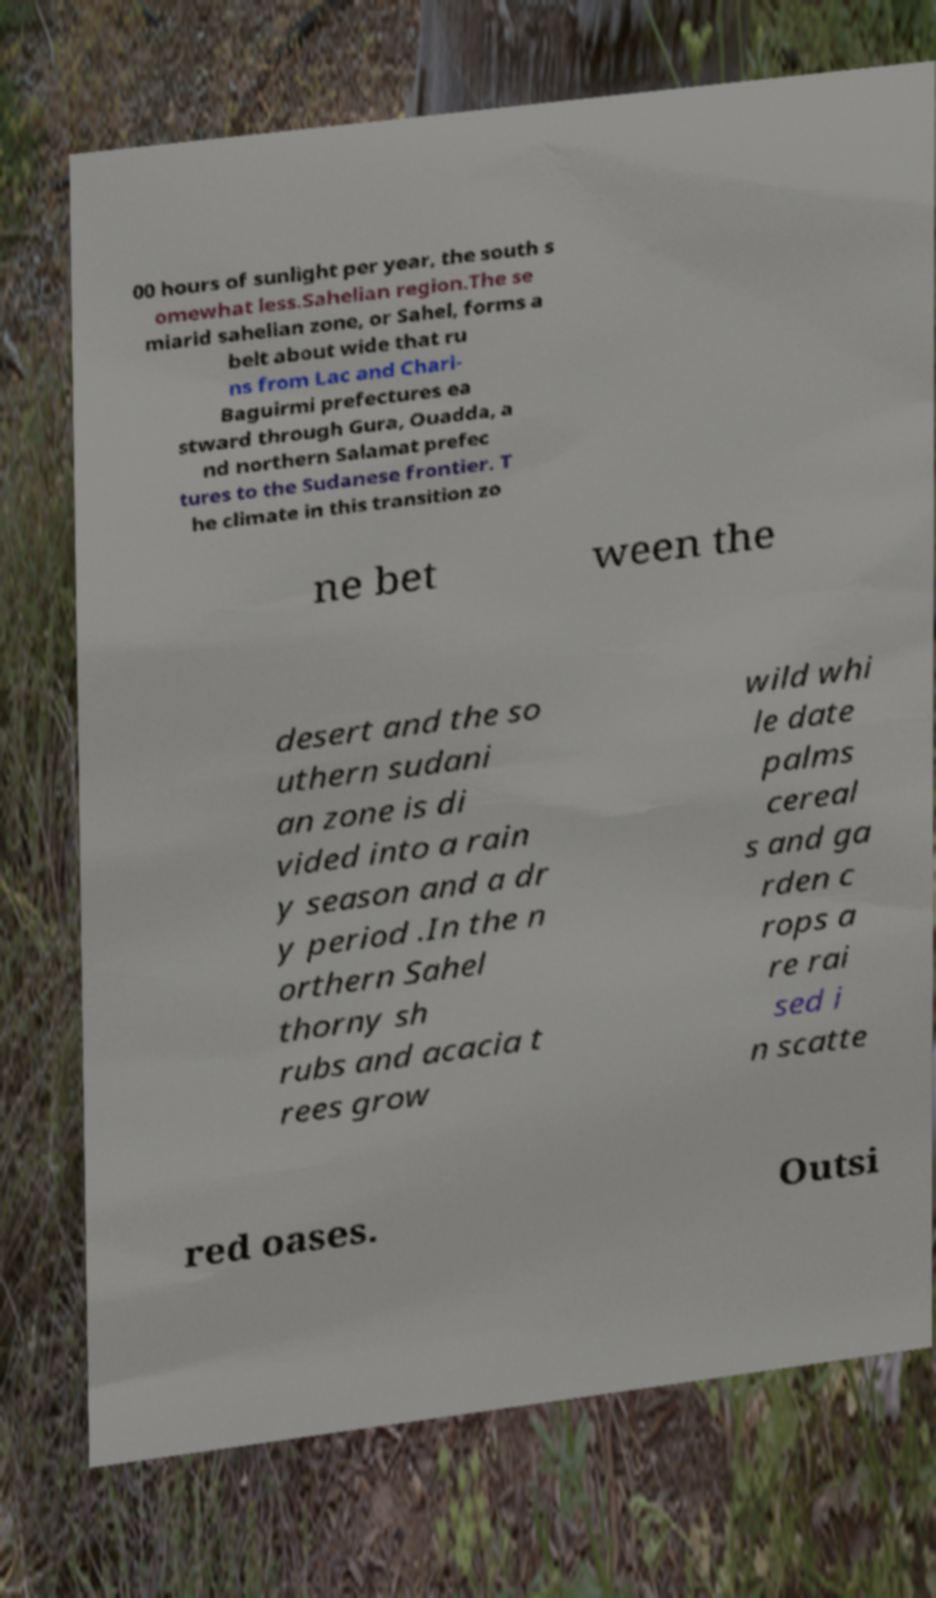Could you extract and type out the text from this image? 00 hours of sunlight per year, the south s omewhat less.Sahelian region.The se miarid sahelian zone, or Sahel, forms a belt about wide that ru ns from Lac and Chari- Baguirmi prefectures ea stward through Gura, Ouadda, a nd northern Salamat prefec tures to the Sudanese frontier. T he climate in this transition zo ne bet ween the desert and the so uthern sudani an zone is di vided into a rain y season and a dr y period .In the n orthern Sahel thorny sh rubs and acacia t rees grow wild whi le date palms cereal s and ga rden c rops a re rai sed i n scatte red oases. Outsi 